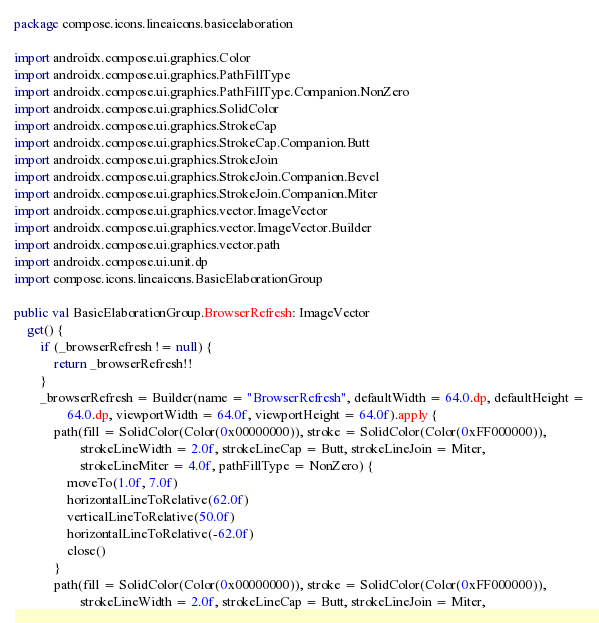<code> <loc_0><loc_0><loc_500><loc_500><_Kotlin_>package compose.icons.lineaicons.basicelaboration

import androidx.compose.ui.graphics.Color
import androidx.compose.ui.graphics.PathFillType
import androidx.compose.ui.graphics.PathFillType.Companion.NonZero
import androidx.compose.ui.graphics.SolidColor
import androidx.compose.ui.graphics.StrokeCap
import androidx.compose.ui.graphics.StrokeCap.Companion.Butt
import androidx.compose.ui.graphics.StrokeJoin
import androidx.compose.ui.graphics.StrokeJoin.Companion.Bevel
import androidx.compose.ui.graphics.StrokeJoin.Companion.Miter
import androidx.compose.ui.graphics.vector.ImageVector
import androidx.compose.ui.graphics.vector.ImageVector.Builder
import androidx.compose.ui.graphics.vector.path
import androidx.compose.ui.unit.dp
import compose.icons.lineaicons.BasicElaborationGroup

public val BasicElaborationGroup.BrowserRefresh: ImageVector
    get() {
        if (_browserRefresh != null) {
            return _browserRefresh!!
        }
        _browserRefresh = Builder(name = "BrowserRefresh", defaultWidth = 64.0.dp, defaultHeight =
                64.0.dp, viewportWidth = 64.0f, viewportHeight = 64.0f).apply {
            path(fill = SolidColor(Color(0x00000000)), stroke = SolidColor(Color(0xFF000000)),
                    strokeLineWidth = 2.0f, strokeLineCap = Butt, strokeLineJoin = Miter,
                    strokeLineMiter = 4.0f, pathFillType = NonZero) {
                moveTo(1.0f, 7.0f)
                horizontalLineToRelative(62.0f)
                verticalLineToRelative(50.0f)
                horizontalLineToRelative(-62.0f)
                close()
            }
            path(fill = SolidColor(Color(0x00000000)), stroke = SolidColor(Color(0xFF000000)),
                    strokeLineWidth = 2.0f, strokeLineCap = Butt, strokeLineJoin = Miter,</code> 